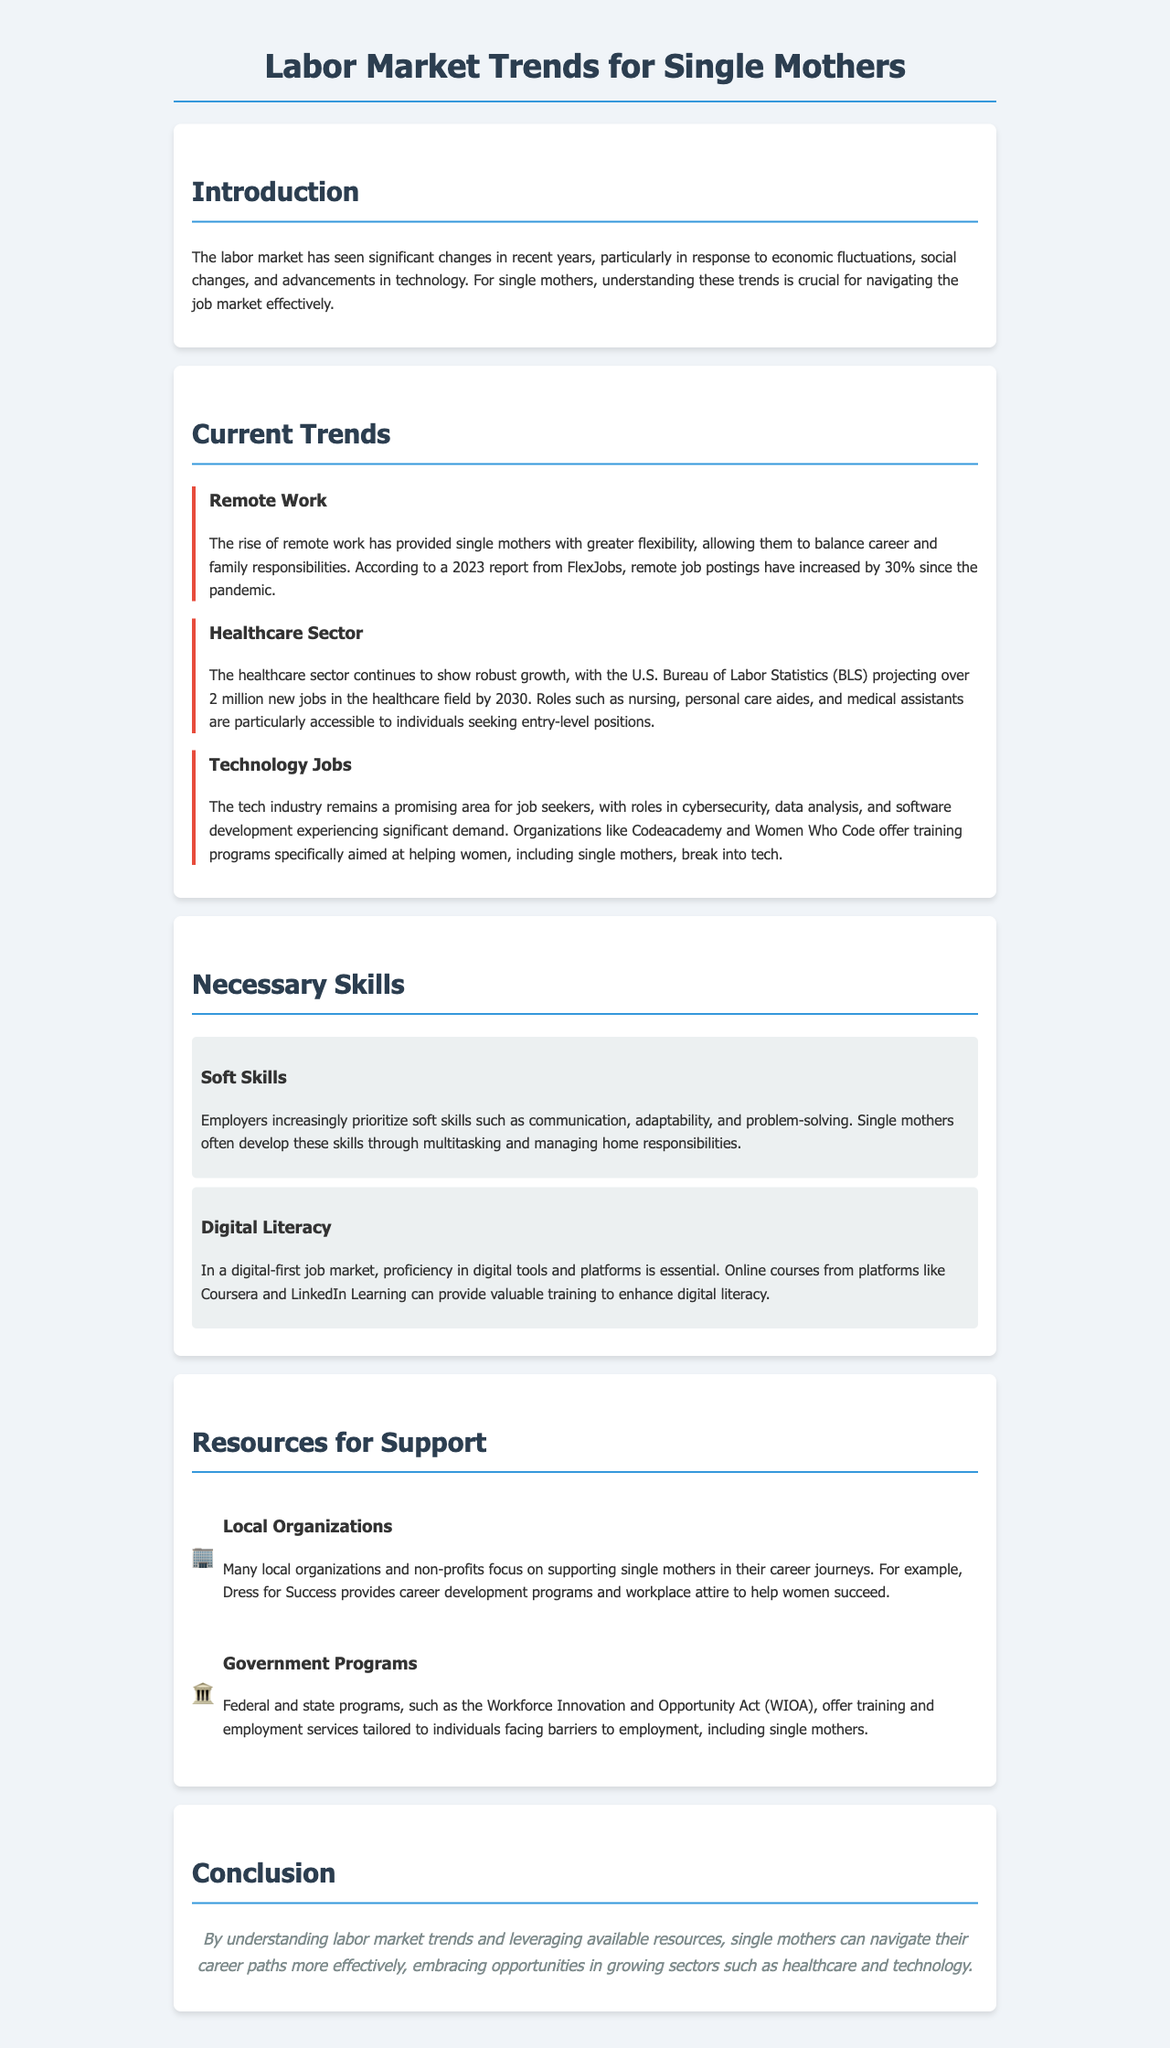What percentage increase in remote job postings has been reported since the pandemic? The document states that remote job postings have increased by 30% since the pandemic.
Answer: 30% How many new jobs in the healthcare sector is the BLS projecting by 2030? According to the document, the U.S. Bureau of Labor Statistics projects over 2 million new jobs in the healthcare field by 2030.
Answer: 2 million Which industry is noted for significant roles in cybersecurity, data analysis, and software development? The technology industry is highlighted in the document for experiencing significant demand in roles such as cybersecurity, data analysis, and software development.
Answer: Technology What skills do employers increasingly prioritize according to the report? The document emphasizes that employers prioritize soft skills such as communication, adaptability, and problem-solving.
Answer: Soft skills What is the name of the organization that provides career development programs for women? The document mentions Dress for Success as a local organization that provides career development programs for women.
Answer: Dress for Success Which federal act offers training and employment services tailored to individuals facing barriers to employment? The Workforce Innovation and Opportunity Act (WIOA) is mentioned in the document as a federal program offering training and employment services.
Answer: WIOA What is the overall goal for single mothers in navigating the labor market? The conclusion of the document indicates that understanding labor market trends and leveraging available resources help single mothers navigate their career paths more effectively.
Answer: Navigate career paths How significant has the growth been in the healthcare sector for job opportunities? The report describes the healthcare sector as showing robust growth with over 2 million new jobs projected by 2030, indicating significant growth in job opportunities.
Answer: Robust growth 